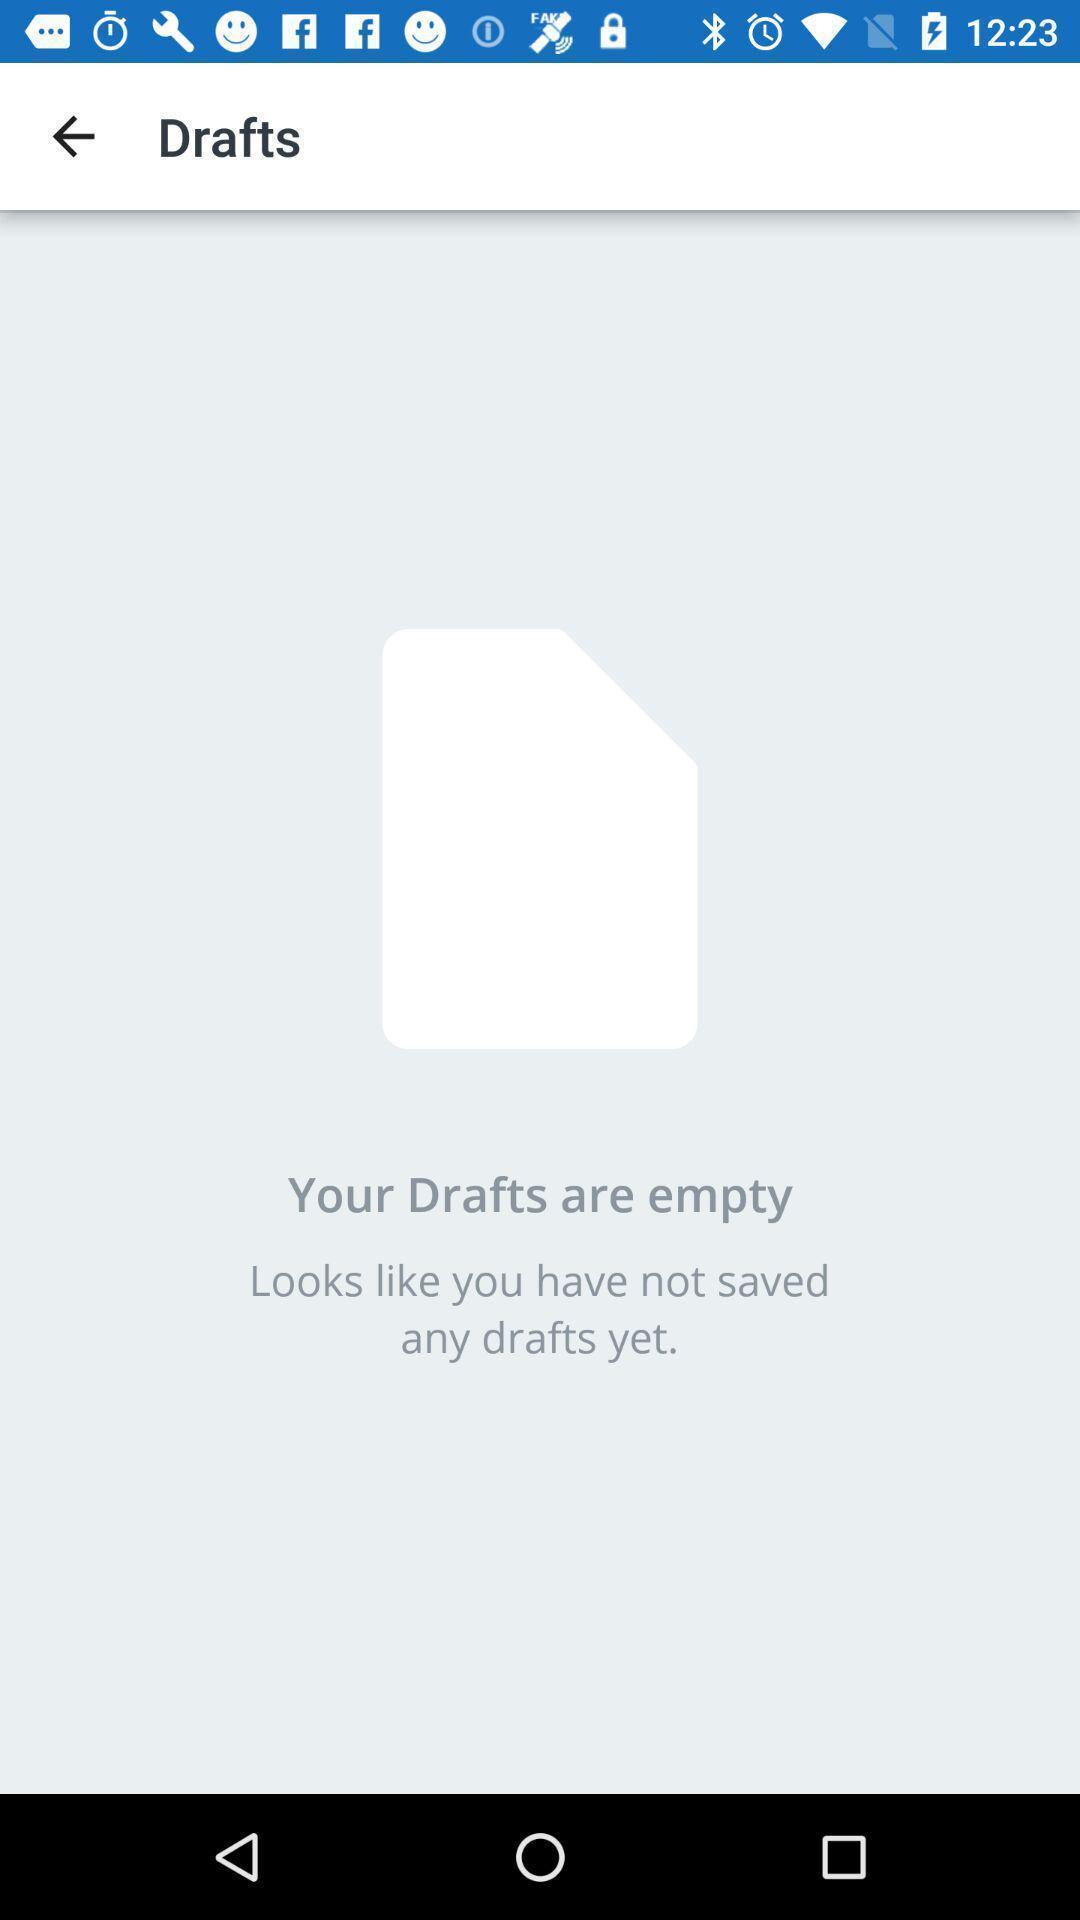What is the overall content of this screenshot? Page showing your drafts are empty. 